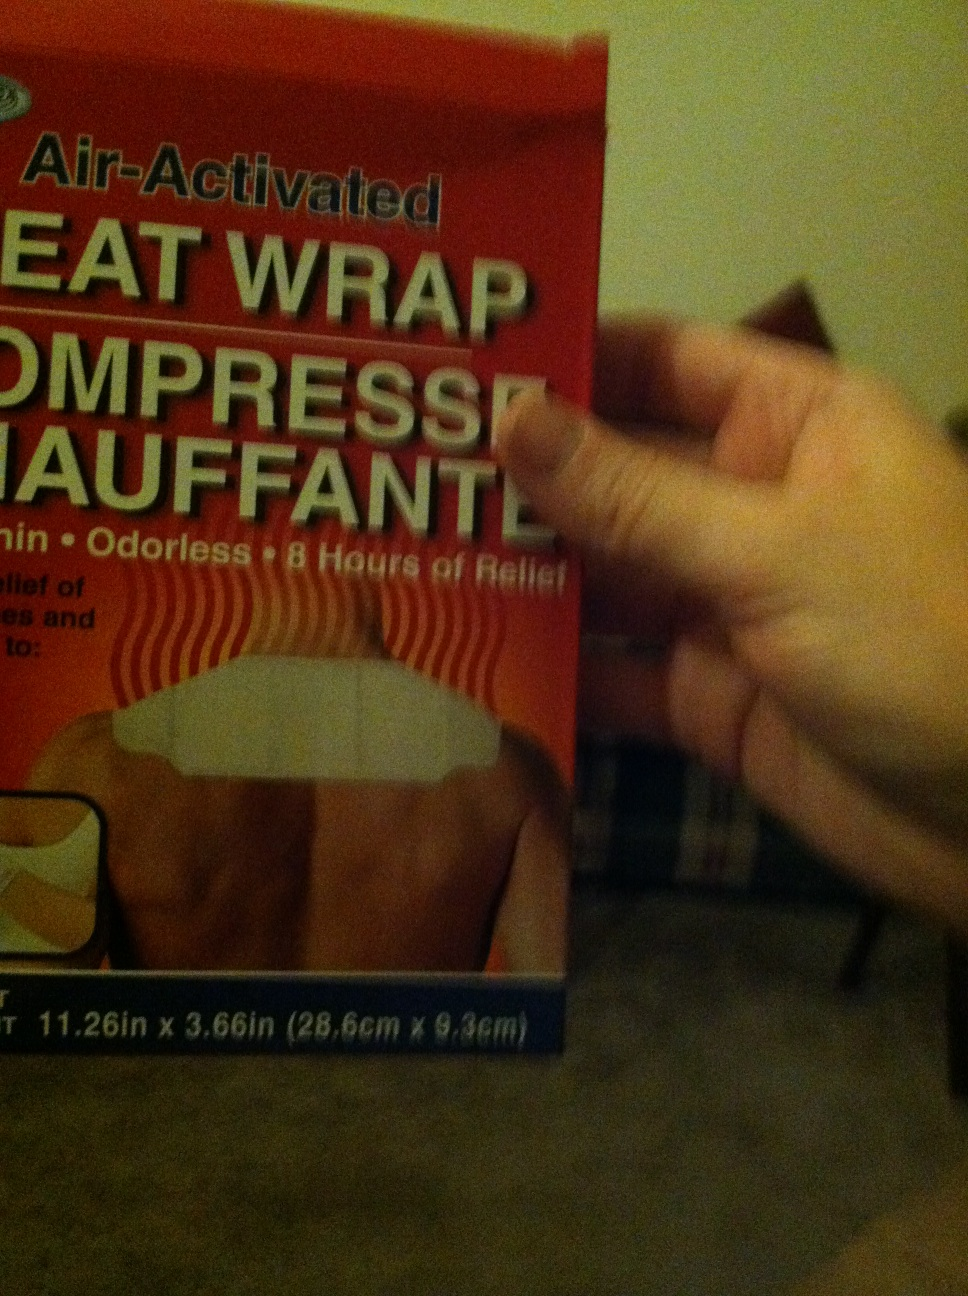Is it safe for everyone? Heat wraps are generally safe for adults, but they should be used with caution. People with sensitive skin, circulatory issues, diabetes, or who are pregnant should consult a healthcare provider before use. Always follow the product's enclosed instructions to avoid burns or skin damage. 